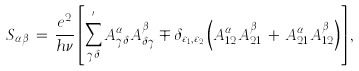<formula> <loc_0><loc_0><loc_500><loc_500>S _ { \alpha \beta } \, = \, \frac { e ^ { 2 } } { h \nu } \left [ \sum _ { \gamma \delta } ^ { ^ { \prime } } A _ { \gamma \delta } ^ { \alpha } A _ { \delta \gamma } ^ { \beta } \mp \delta _ { \varepsilon _ { 1 } , \varepsilon _ { 2 } } \left ( A _ { 1 2 } ^ { \alpha } A _ { 2 1 } ^ { \beta } \, + \, A _ { 2 1 } ^ { \alpha } A _ { 1 2 } ^ { \beta } \right ) \right ] ,</formula> 